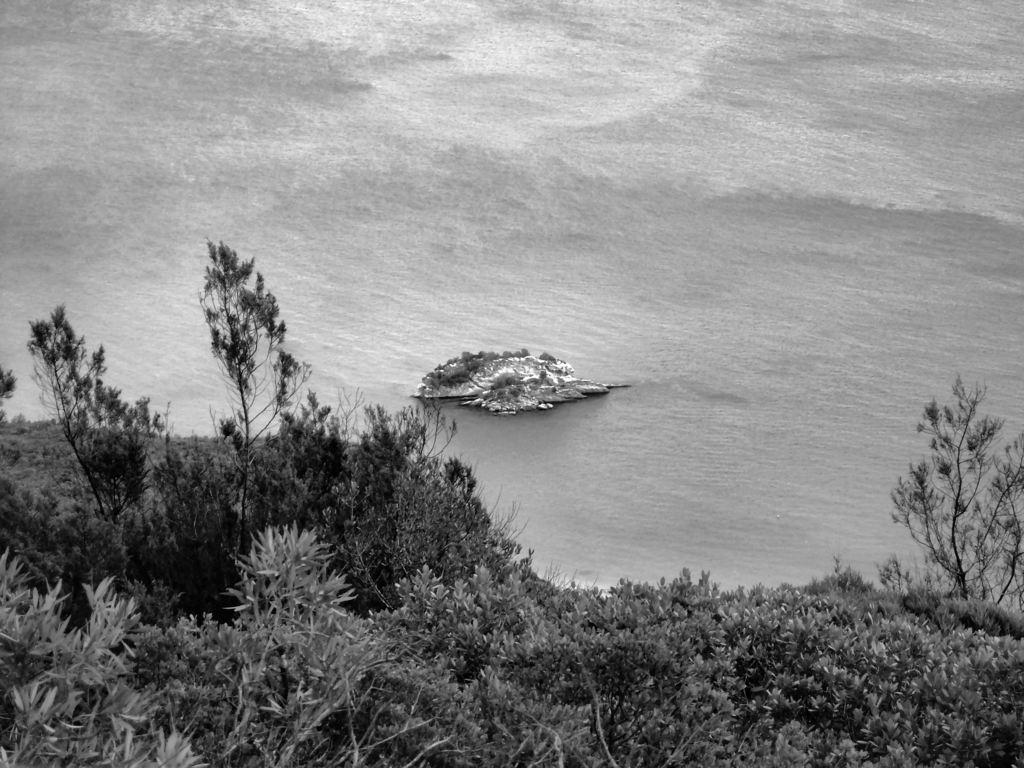What type of surface can be seen in the image? There is ground visible in the image. What type of vegetation is present in the image? There are plants and trees in the image. What natural element is visible in the image? There is water visible in the image. What is located in the water in the image? There is an object in the water. What type of rice is being served in the pie in the image? There is no rice or pie present in the image. What color is the sky in the image? The provided facts do not mention the sky, so we cannot determine its color from the image. 